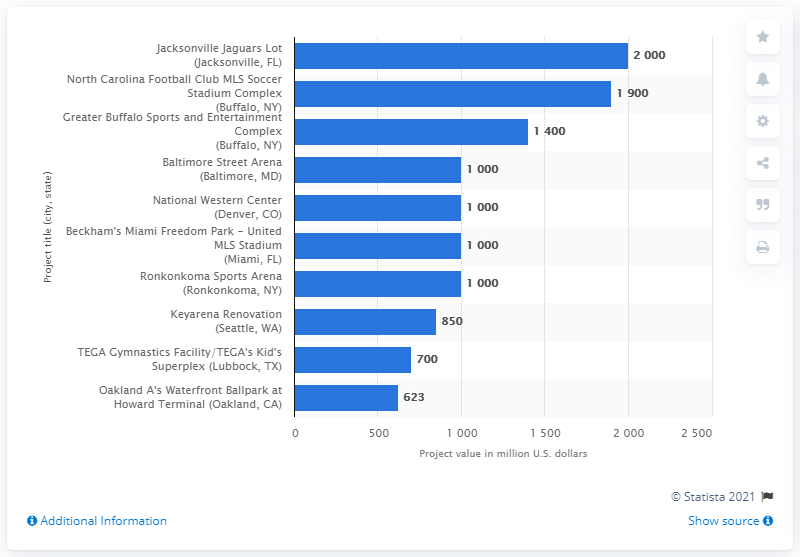Outline some significant characteristics in this image. The National Western Center project was worth an estimated 1000. 